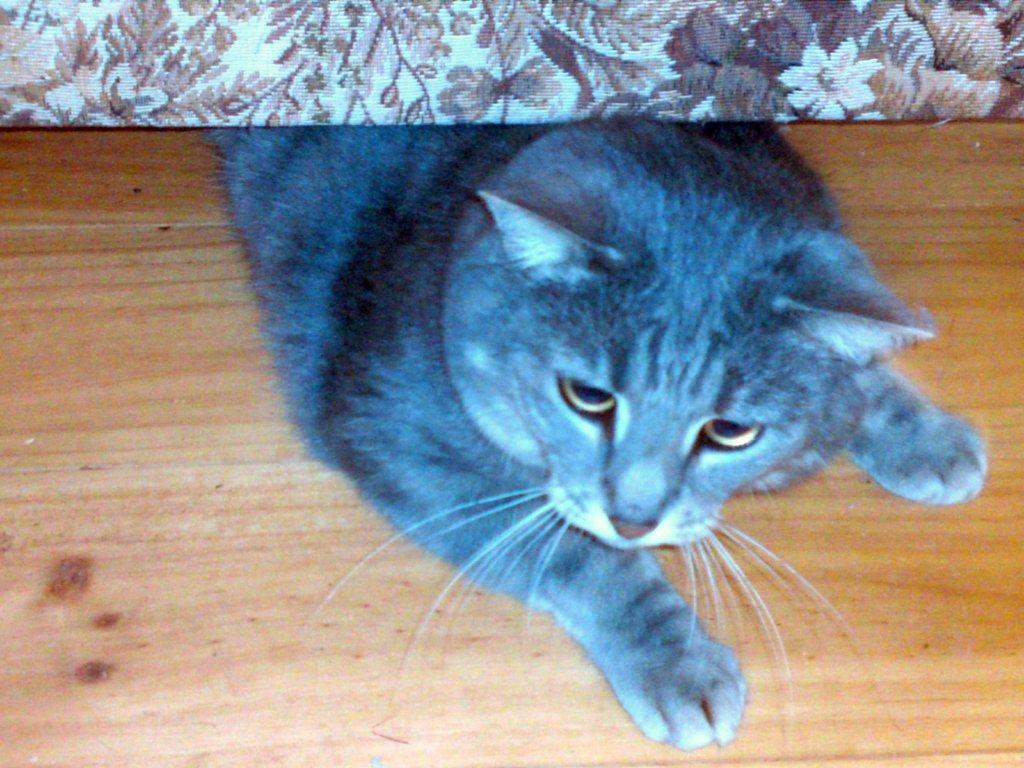What animal is present in the image? There is a cat in the image. What type of surface is the cat on? The cat is on a wooden floor. What can be seen at the top of the image? There is a cloth visible at the top of the image. What is the purpose of the cream in the image? There is no cream present in the image. 